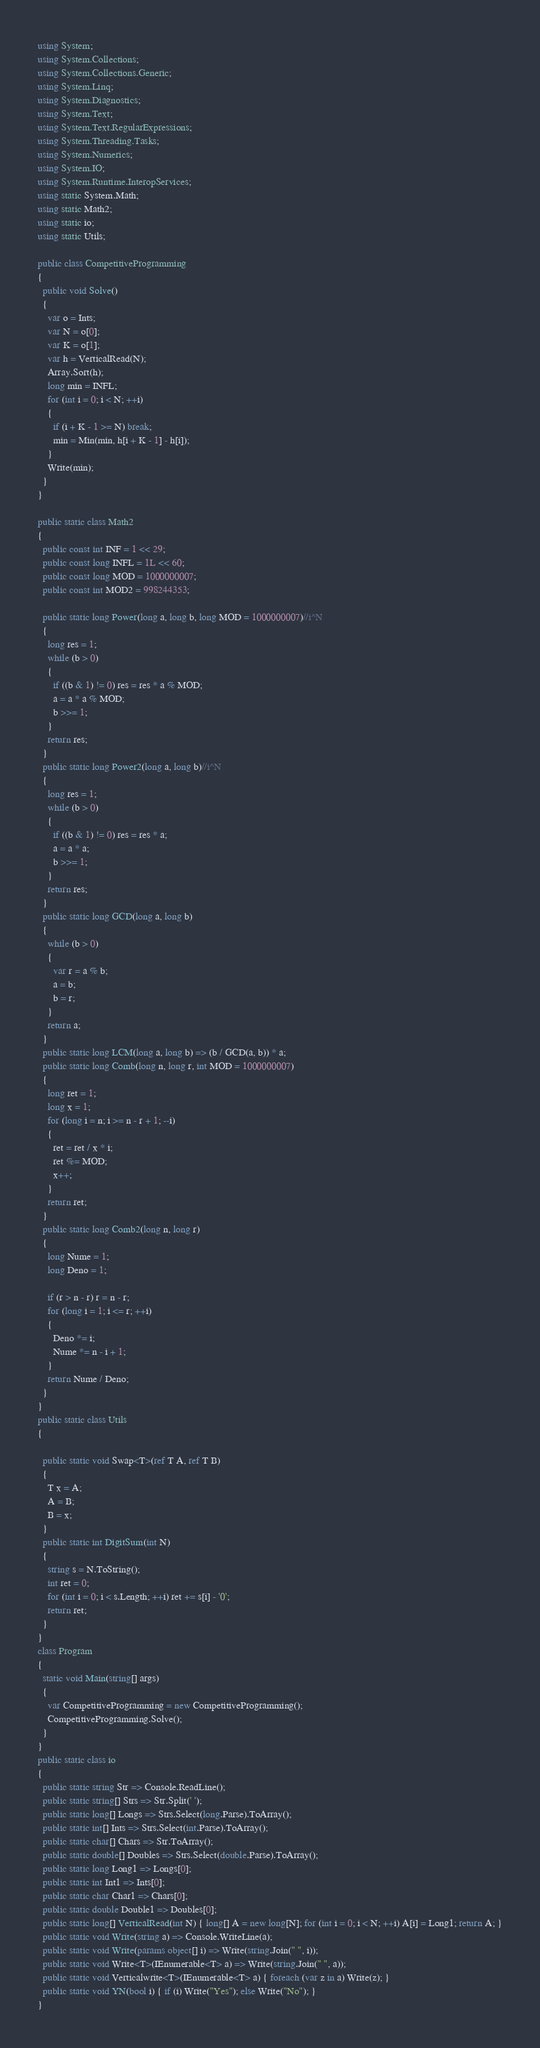<code> <loc_0><loc_0><loc_500><loc_500><_C#_>using System;
using System.Collections;
using System.Collections.Generic;
using System.Linq;
using System.Diagnostics;
using System.Text;
using System.Text.RegularExpressions;
using System.Threading.Tasks;
using System.Numerics;
using System.IO;
using System.Runtime.InteropServices;
using static System.Math;
using static Math2;
using static io;
using static Utils;

public class CompetitiveProgramming
{
  public void Solve()
  {
    var o = Ints;
    var N = o[0];
    var K = o[1];
    var h = VerticalRead(N);
    Array.Sort(h);
    long min = INFL;
    for (int i = 0; i < N; ++i)
    {
      if (i + K - 1 >= N) break;
      min = Min(min, h[i + K - 1] - h[i]);
    }
    Write(min);
  }
}

public static class Math2
{
  public const int INF = 1 << 29;
  public const long INFL = 1L << 60;
  public const long MOD = 1000000007;
  public const int MOD2 = 998244353;

  public static long Power(long a, long b, long MOD = 1000000007)//i^N
  {
    long res = 1;
    while (b > 0)
    {
      if ((b & 1) != 0) res = res * a % MOD;
      a = a * a % MOD;
      b >>= 1;
    }
    return res;
  }
  public static long Power2(long a, long b)//i^N
  {
    long res = 1;
    while (b > 0)
    {
      if ((b & 1) != 0) res = res * a;
      a = a * a;
      b >>= 1;
    }
    return res;
  }
  public static long GCD(long a, long b)
  {
    while (b > 0)
    {
      var r = a % b;
      a = b;
      b = r;
    }
    return a;
  }
  public static long LCM(long a, long b) => (b / GCD(a, b)) * a;
  public static long Comb(long n, long r, int MOD = 1000000007)
  {
    long ret = 1;
    long x = 1;
    for (long i = n; i >= n - r + 1; --i)
    {
      ret = ret / x * i;
      ret %= MOD;
      x++;
    }
    return ret;
  }
  public static long Comb2(long n, long r)
  {
    long Nume = 1;
    long Deno = 1;

    if (r > n - r) r = n - r;
    for (long i = 1; i <= r; ++i)
    {
      Deno *= i;
      Nume *= n - i + 1;
    }
    return Nume / Deno;
  }
}
public static class Utils
{

  public static void Swap<T>(ref T A, ref T B)
  {
    T x = A;
    A = B;
    B = x;
  }
  public static int DigitSum(int N)
  {
    string s = N.ToString();
    int ret = 0;
    for (int i = 0; i < s.Length; ++i) ret += s[i] - '0';
    return ret;
  }
}
class Program
{
  static void Main(string[] args)
  {
    var CompetitiveProgramming = new CompetitiveProgramming();
    CompetitiveProgramming.Solve();
  }
}
public static class io
{
  public static string Str => Console.ReadLine();
  public static string[] Strs => Str.Split(' ');
  public static long[] Longs => Strs.Select(long.Parse).ToArray();
  public static int[] Ints => Strs.Select(int.Parse).ToArray();
  public static char[] Chars => Str.ToArray();
  public static double[] Doubles => Strs.Select(double.Parse).ToArray();
  public static long Long1 => Longs[0];
  public static int Int1 => Ints[0];
  public static char Char1 => Chars[0];
  public static double Double1 => Doubles[0];
  public static long[] VerticalRead(int N) { long[] A = new long[N]; for (int i = 0; i < N; ++i) A[i] = Long1; return A; }
  public static void Write(string a) => Console.WriteLine(a);
  public static void Write(params object[] i) => Write(string.Join(" ", i));
  public static void Write<T>(IEnumerable<T> a) => Write(string.Join(" ", a));
  public static void Verticalwrite<T>(IEnumerable<T> a) { foreach (var z in a) Write(z); }
  public static void YN(bool i) { if (i) Write("Yes"); else Write("No"); }
}
</code> 